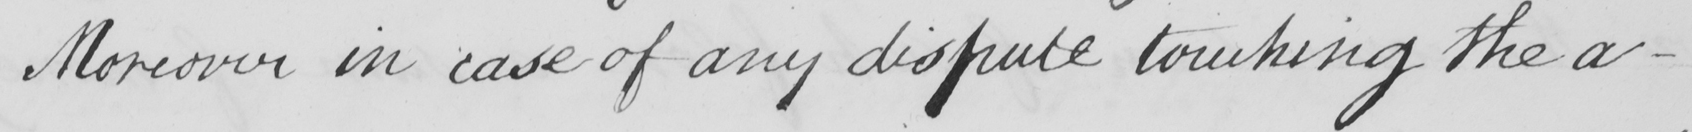Can you tell me what this handwritten text says? Moreover in case of any dispute touching the a- 